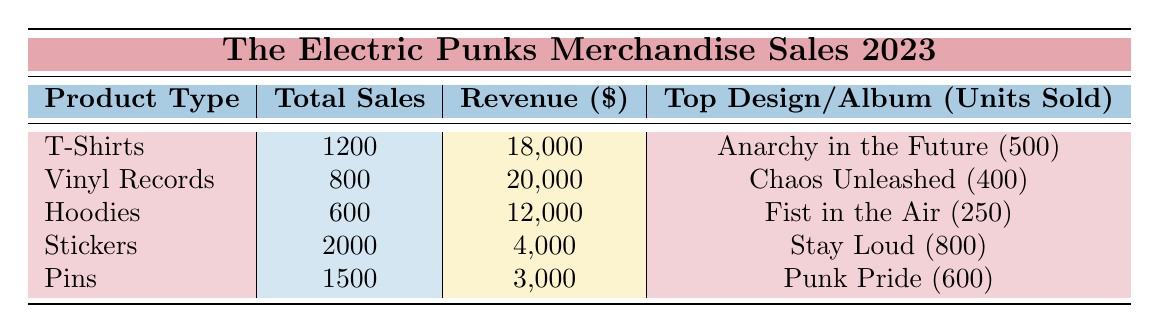What is the total revenue from T-shirt sales? The total revenue for T-shirts is provided directly in the table under the 'Revenue' column, which is $18,000.
Answer: $18,000 How many units of "Anarchy in the Future" T-shirts were sold? The table lists "Anarchy in the Future" under the 'Top Design/Album' for T-shirts, showing that 500 units were sold.
Answer: 500 Which product generated the most revenue? By comparing the revenue figures in the table, Vinyl Records at $20,000 generated the most revenue.
Answer: Vinyl Records What is the total number of units sold across all product types? Adding the total sales from all products: 1200 (T-Shirts) + 800 (Vinyl Records) + 600 (Hoodies) + 2000 (Stickers) + 1500 (Pins) = 5100 units sold.
Answer: 5100 Did the sales of Stickers exceed those of Hoodies? By examining the total sales figures, Stickers sold 2000 units while Hoodies sold only 600 units, confirming that Stickers exceeded Hoodies.
Answer: Yes What is the average revenue per product type? The total revenue is $18,000 + $20,000 + $12,000 + $4,000 + $3,000 = $57,000. We have 5 product types, so the average revenue is $57,000 / 5 = $11,400.
Answer: $11,400 Which product had the lowest total sales? The total sales for each product type are compared, and Pins had the lowest total sales of 1500 units.
Answer: Pins What is the difference in units sold between T-Shirts and Vinyl Records? Subtracting the total sales of T-Shirts (1200 units) from Vinyl Records (800 units) gives a difference of 1200 - 800 = 400 units.
Answer: 400 Are there more Pins sold than Hoodies? Looking at the total sales numbers, Pins sold 1500 units while Hoodies sold 600 units, thus confirming that more Pins were sold than Hoodies.
Answer: Yes What is the sum of the units sold for the top design of each product? Adding the units sold of top designs: 500 (T-Shirts) + 400 (Vinyl Records) + 250 (Hoodies) + 800 (Stickers) + 600 (Pins) = 2550 units.
Answer: 2550 